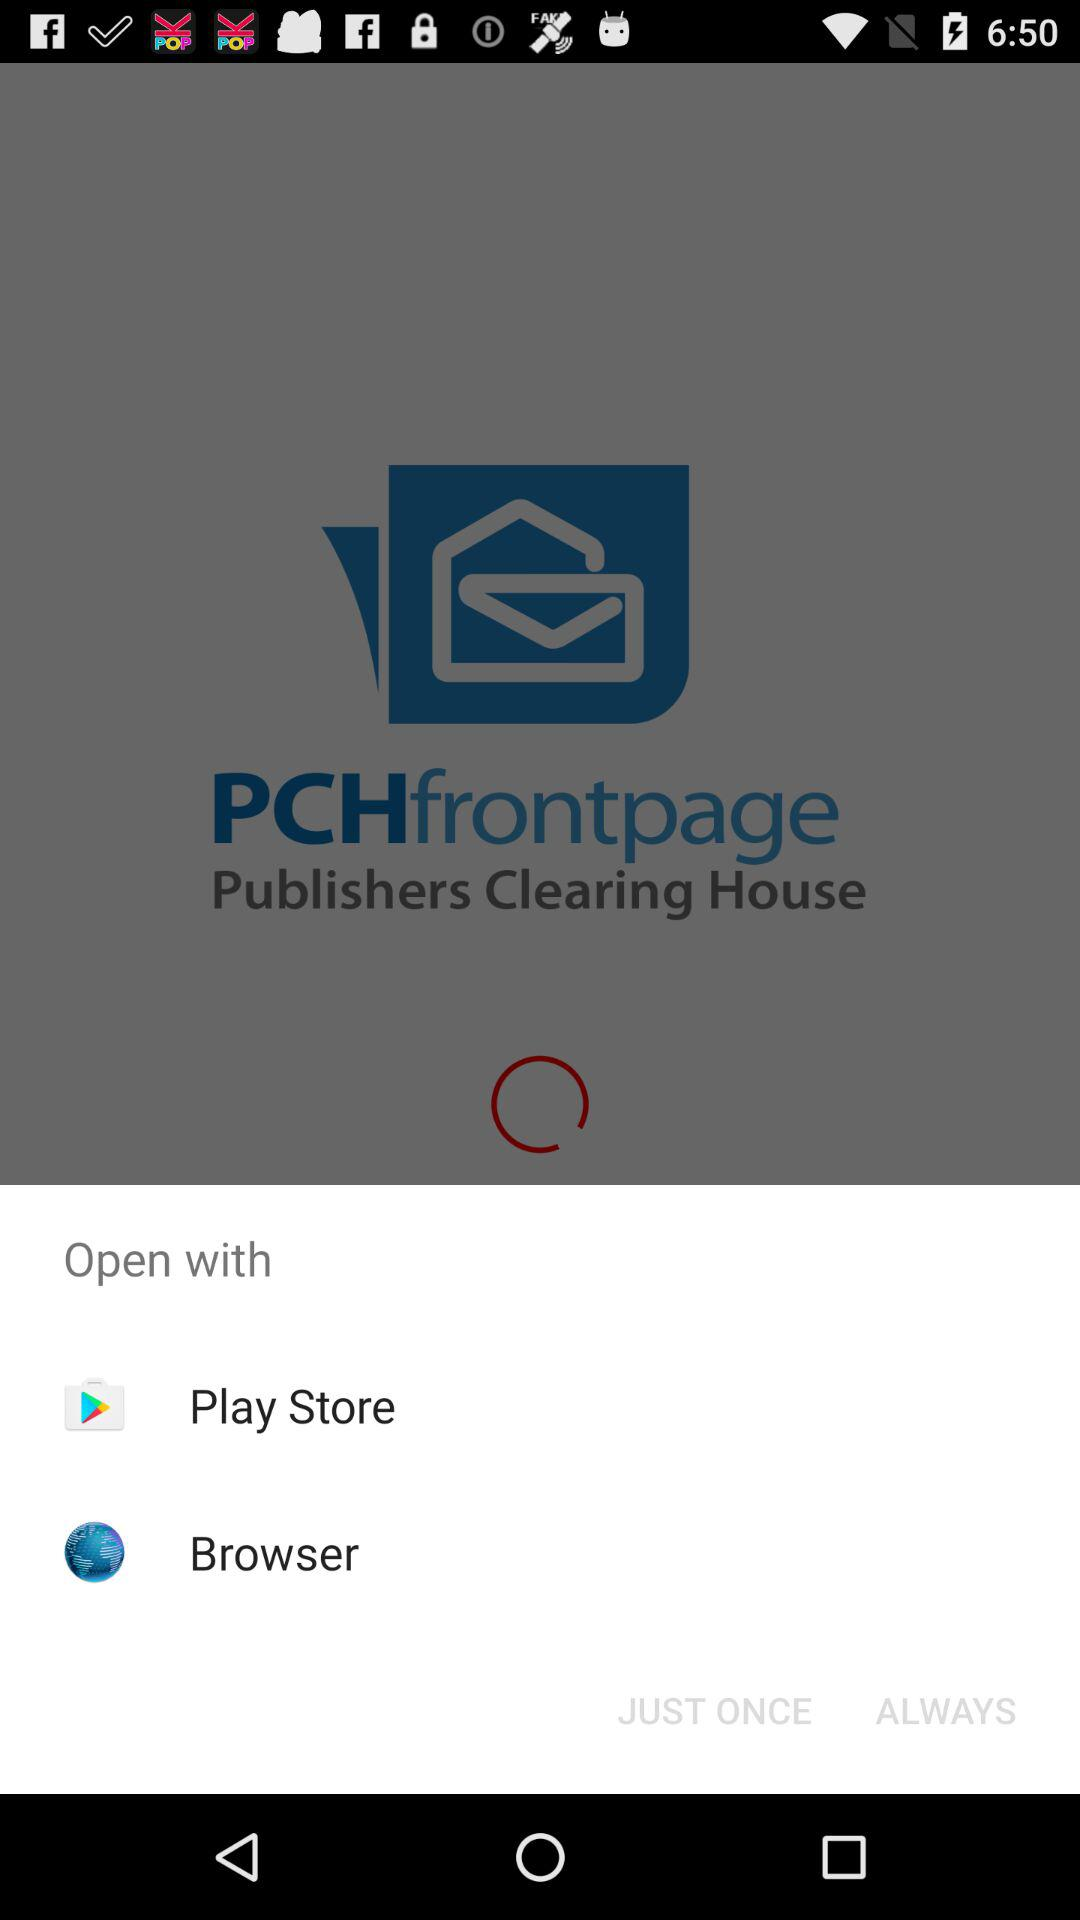Which application can I use to open the content? The application that you can use to open the content is "Play Store". 